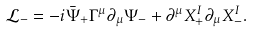Convert formula to latex. <formula><loc_0><loc_0><loc_500><loc_500>\mathcal { L } _ { - } = - i \bar { \Psi } _ { + } \Gamma ^ { \mu } \partial _ { \mu } \Psi _ { - } + \partial ^ { \mu } X _ { + } ^ { I } \partial _ { \mu } X _ { - } ^ { I } .</formula> 